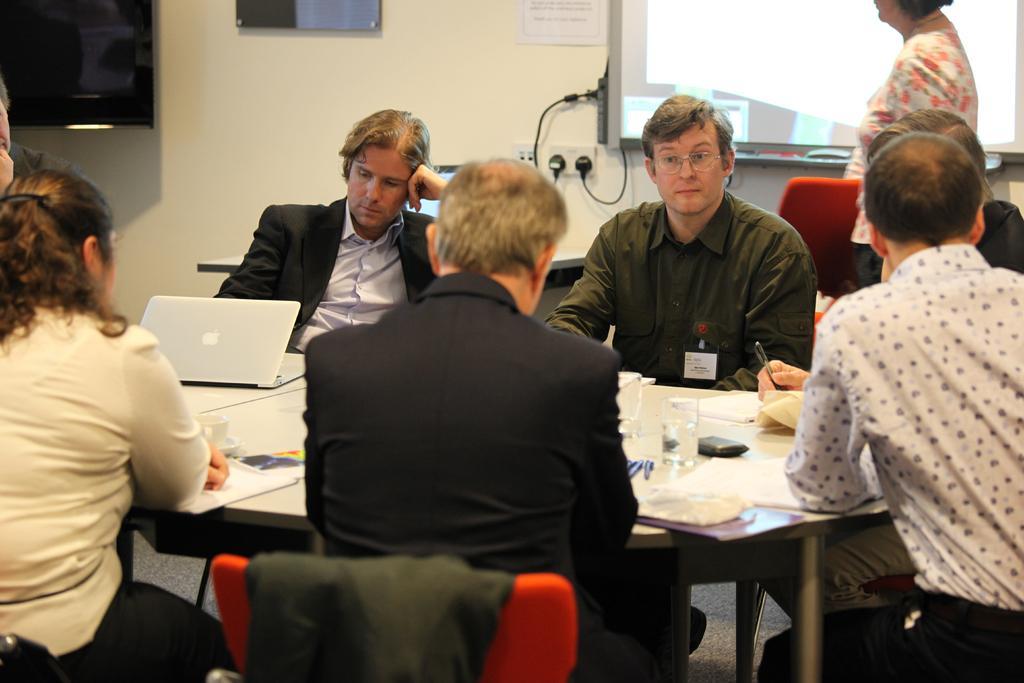In one or two sentences, can you explain what this image depicts? In the image we can see there are many people sitting on the chair, they are wearing clothes. There is a table, on the table, we can see, glass, laptop and papers. Here we can see a projected screen, wall and a cable wire. 